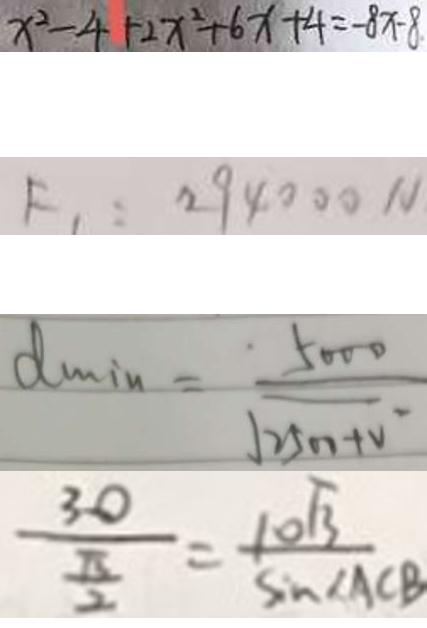Convert formula to latex. <formula><loc_0><loc_0><loc_500><loc_500>x ^ { 2 } - 4 + 2 x ^ { 2 } + 6 x + 4 = - 8 x - 8 
 F _ { 1 } = 2 9 4 0 0 0 N 
 d \min = \frac { 5 0 0 0 } { \sqrt { 2 5 0 0 + v } } 
 \frac { 3 0 } { \frac { \pi } { 2 } } = \frac { 1 0 \sqrt { 3 } } { \sin \angle A C B }</formula> 